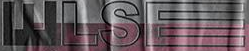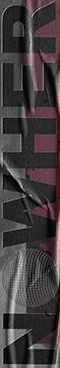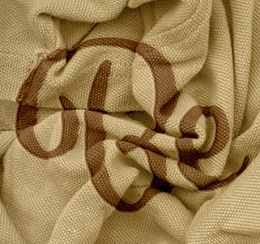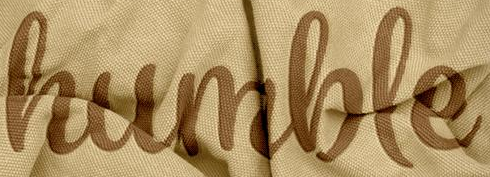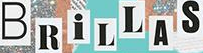What text appears in these images from left to right, separated by a semicolon? WLSE; NOWHER; Be; humble; BRiLLAS 